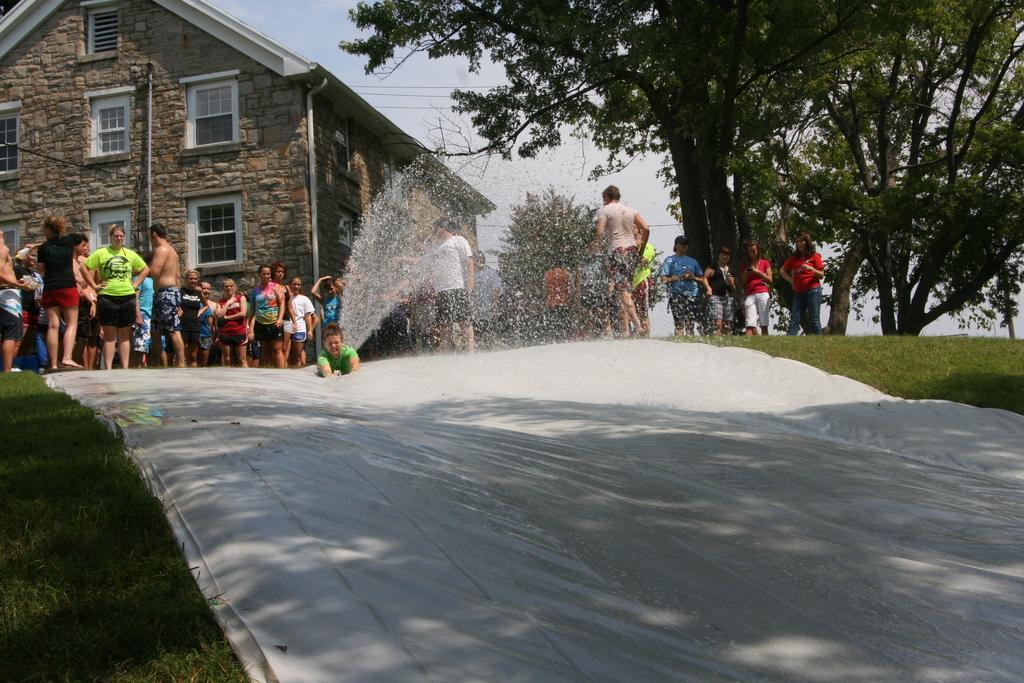How would you summarize this image in a sentence or two? In this image there are group of people standing, at the bottom there is grass and it looks like some snow. And in the background there are some houses, trees, wires. 